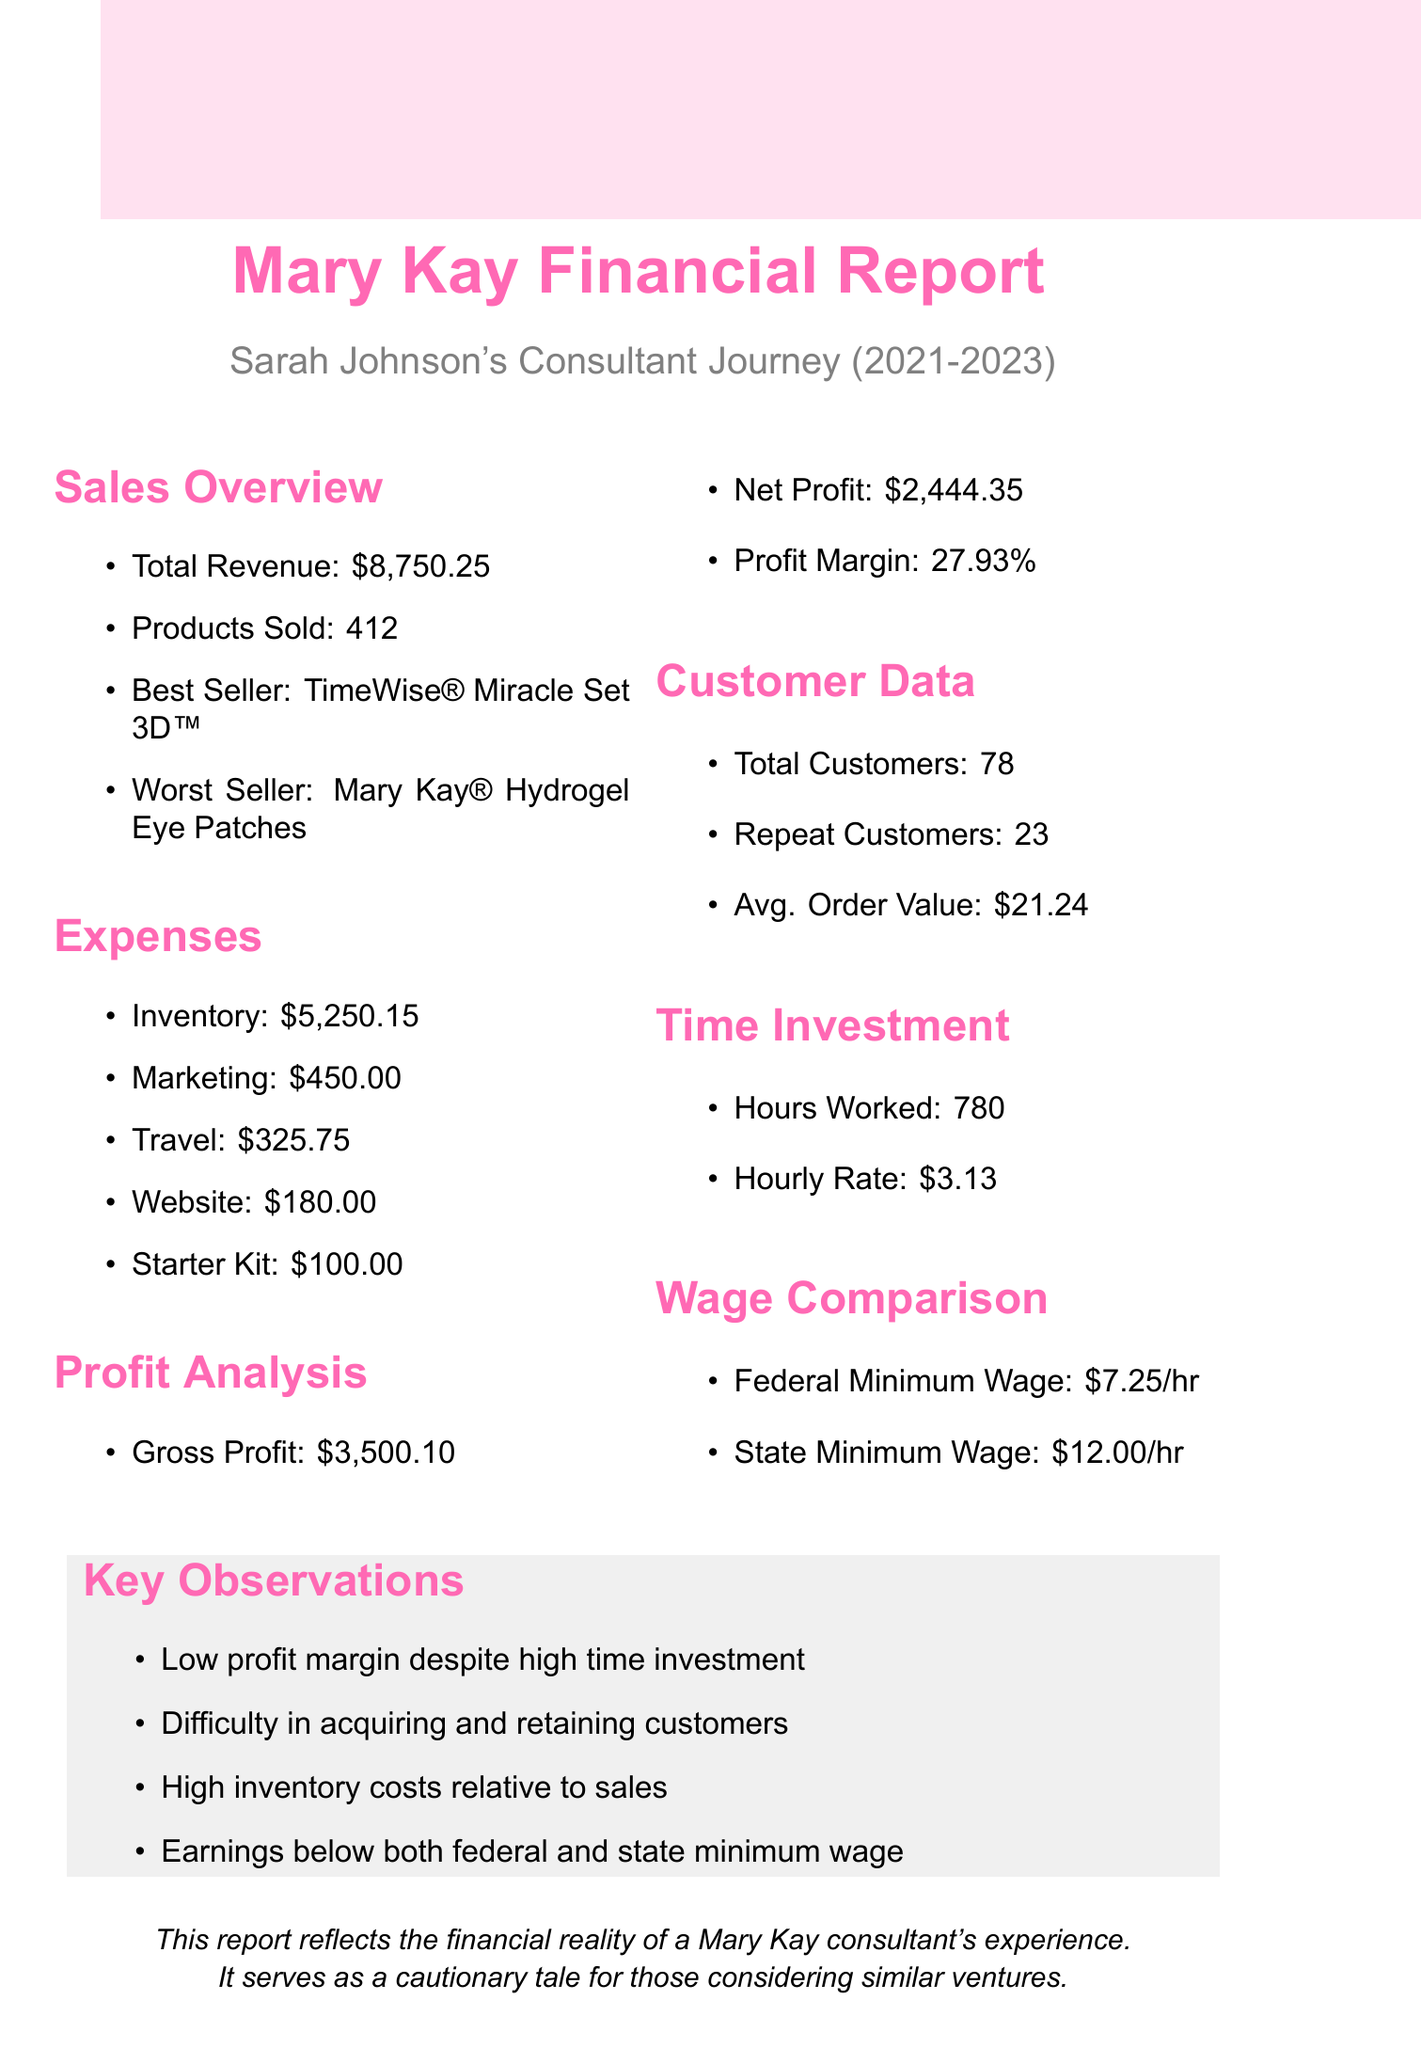what is the total revenue? The total revenue is explicitly stated in the document as the total amount generated from sales activities over the past year, which is $8750.25.
Answer: $8750.25 what is the gross profit? The gross profit is indicated as the total revenue minus the inventory costs and is found to be $3500.10 in the document.
Answer: $3500.10 what is the best selling product? The best selling product is listed in the sales overview section of the document as TimeWise® Miracle Set 3D™.
Answer: TimeWise® Miracle Set 3D™ how many total customers are there? The total number of customers is recorded in the customer data section of the document, which states 78.
Answer: 78 what is the profit margin percentage? The profit margin percentage is detailed as a key financial metric in the profit analysis section, listed as 27.93%.
Answer: 27.93% what are the travel expenses? The travel expenses are outlined in the expenses section of the document, which shows a cost of $325.75.
Answer: $325.75 how many total hours were worked? The document reflects the total hours worked by the consultant as stated in the time investment section, which is 780 hours.
Answer: 780 what are the key observations noted? The key observations are summarized in a specific section and indicate main concerns like low profit margins and high inventory costs.
Answer: Low profit margin despite high time investment what is the average order value? The average order value is captured in the customer data section and is stated as $21.24.
Answer: $21.24 what is the net profit? The net profit represents the profit after expenses and is noted specifically in the profit analysis section, which shows $2444.35.
Answer: $2444.35 